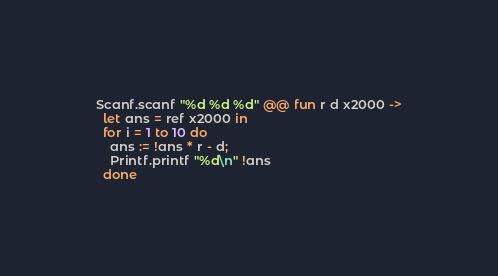<code> <loc_0><loc_0><loc_500><loc_500><_OCaml_>Scanf.scanf "%d %d %d" @@ fun r d x2000 ->
  let ans = ref x2000 in
  for i = 1 to 10 do
    ans := !ans * r - d;
    Printf.printf "%d\n" !ans 
  done</code> 